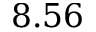Convert formula to latex. <formula><loc_0><loc_0><loc_500><loc_500>8 . 5 6</formula> 